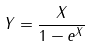Convert formula to latex. <formula><loc_0><loc_0><loc_500><loc_500>Y = \frac { X } { 1 - e ^ { X } }</formula> 